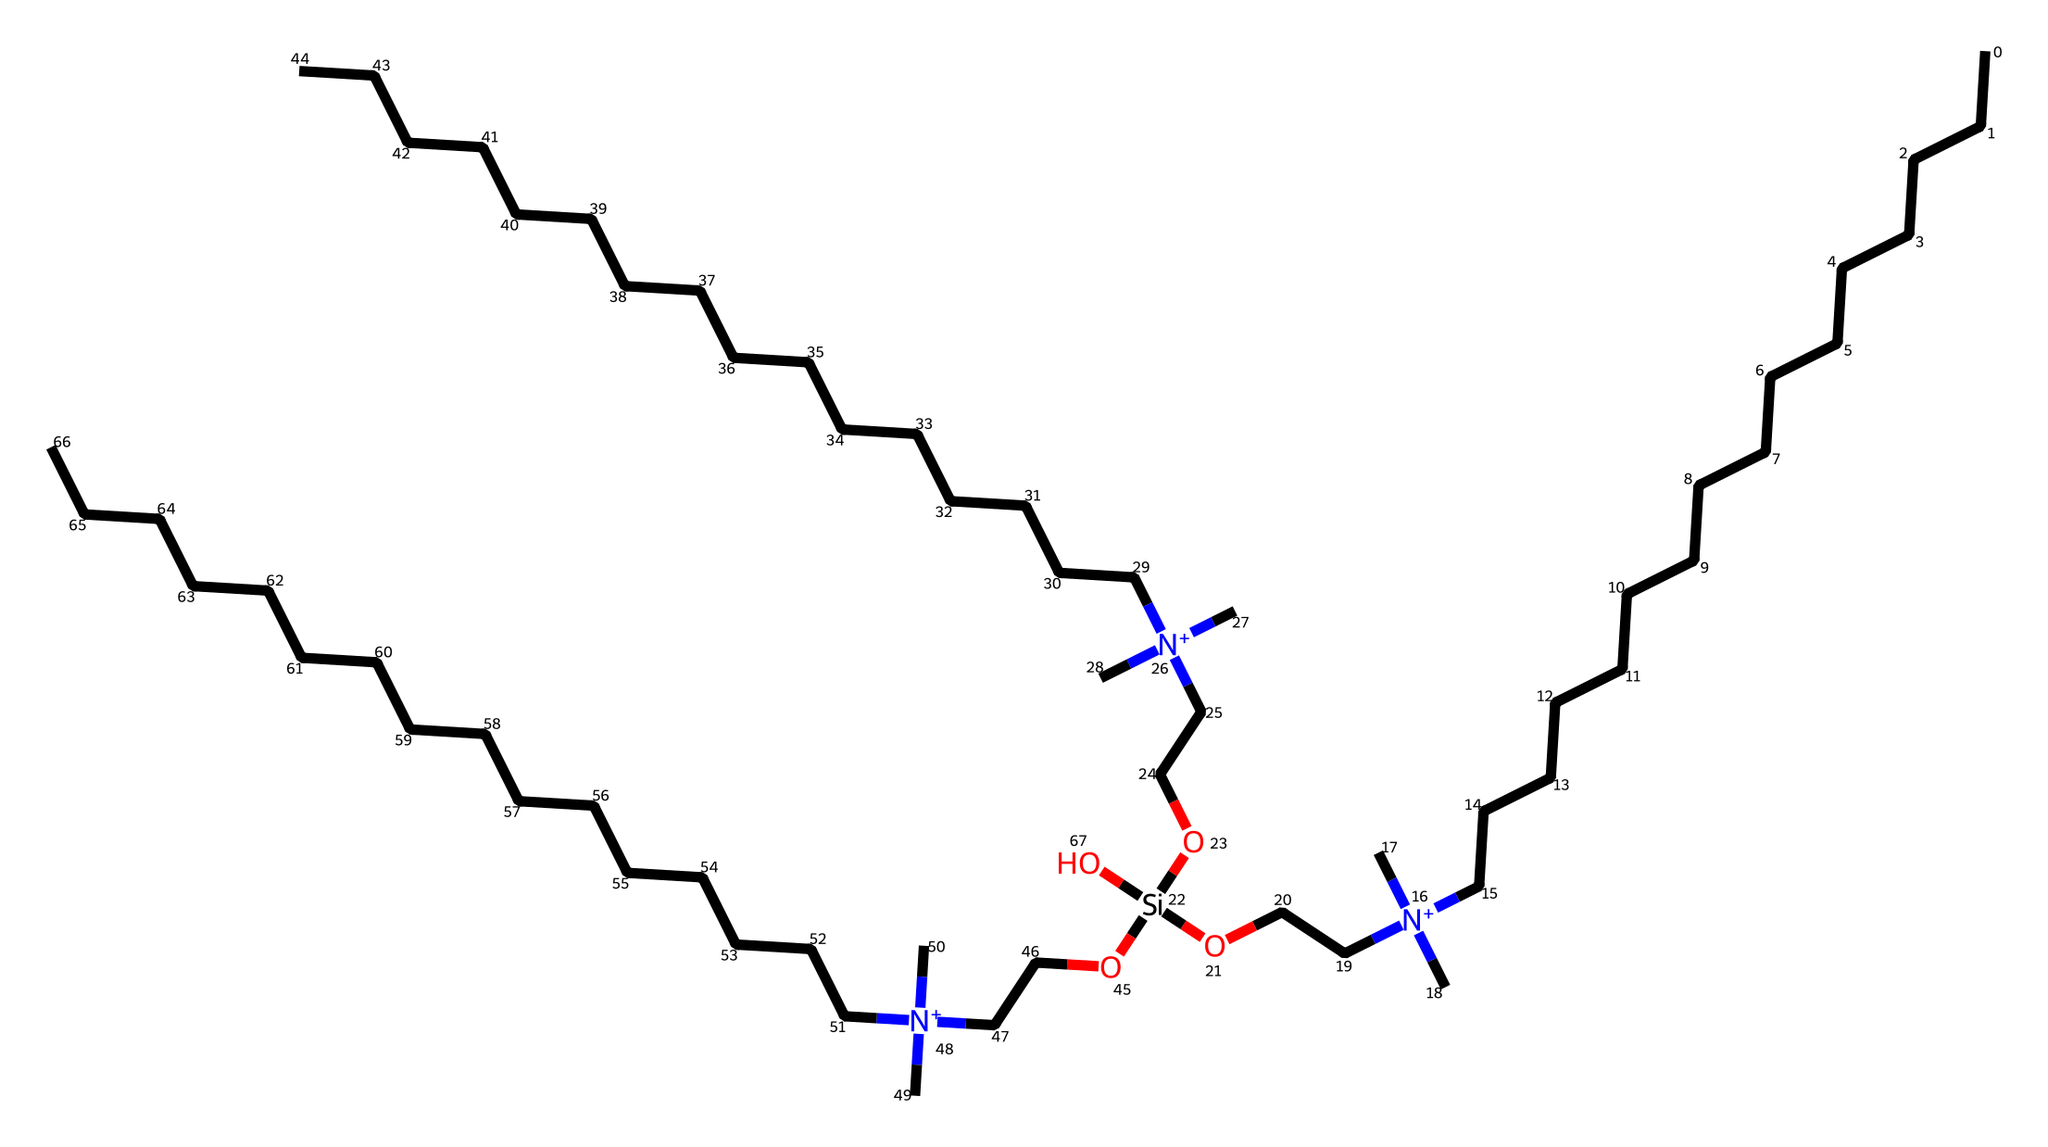What is the total number of carbon atoms in the chemical structure? Count the 'C' symbols in the SMILES representation. Each represents a carbon atom. There are 30 carbon atoms in total.
Answer: 30 What type of functional group is present in this detergent structure? Identify the quaternary ammonium group indicated by the [N+] symbol in the SMILES. This signifies that the chemical is a type of surfactant, common in detergents.
Answer: quaternary ammonium How many ethylene glycol (OCC) units are present in the structure? The OCC segments are part of the chemical structure indicated by the SMILES. In the given structure, there are three OCC units connected to the nitrogen atoms.
Answer: 3 Which part of the chemical is responsible for lowering the surface tension? Surfactants, like the quaternary ammonium groups present in the structure, lower surface tension due to their hydrophilic and hydrophobic parts. This property is crucial in detergents for cleaning.
Answer: quaternary ammonium What property does this detergent provide to fabric softeners? The chemical structure has long hydrophobic alkyl chains, which contribute to flexibility and softness in fabrics by reducing static cling and improving texture.
Answer: flexibility 